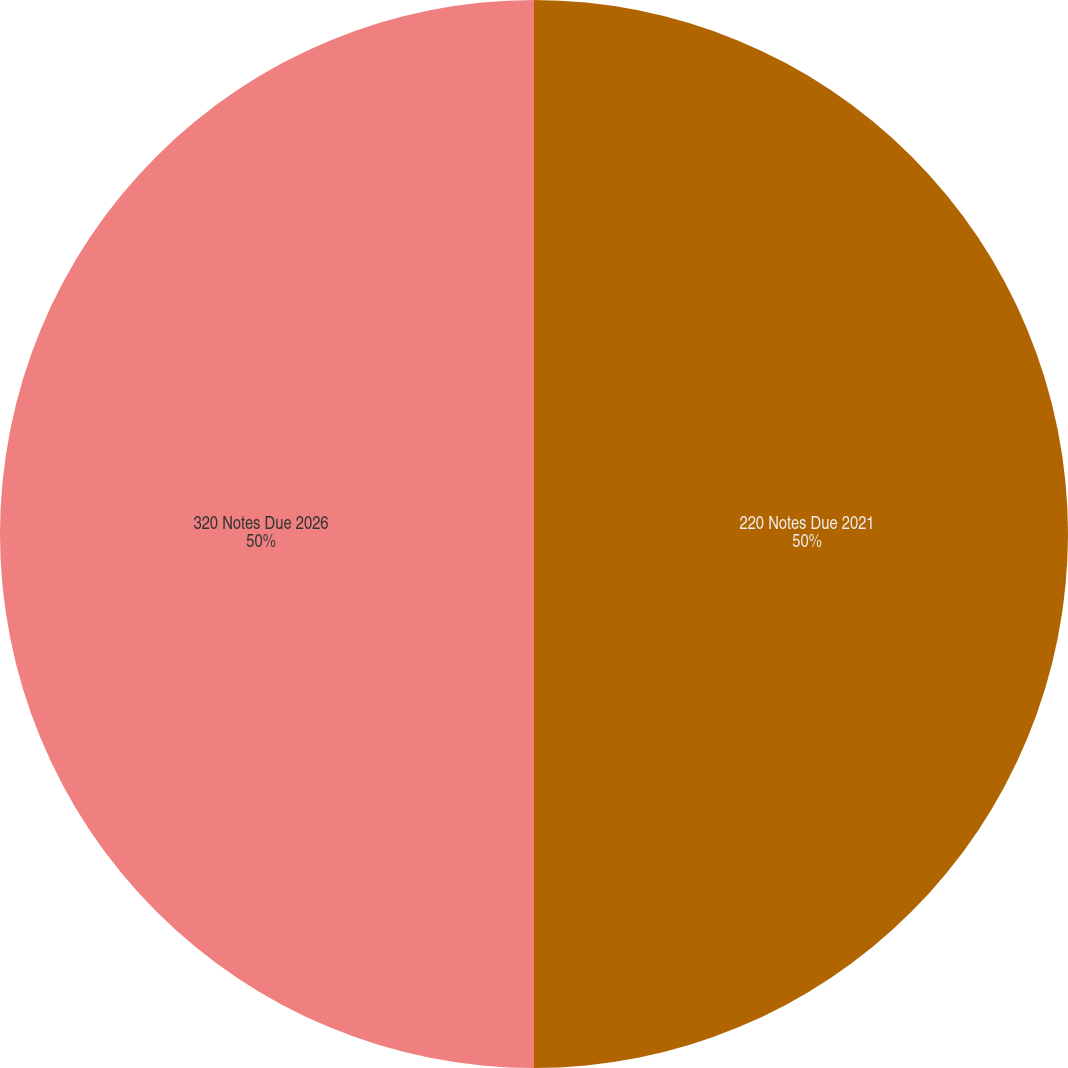Convert chart to OTSL. <chart><loc_0><loc_0><loc_500><loc_500><pie_chart><fcel>220 Notes Due 2021<fcel>320 Notes Due 2026<nl><fcel>50.0%<fcel>50.0%<nl></chart> 